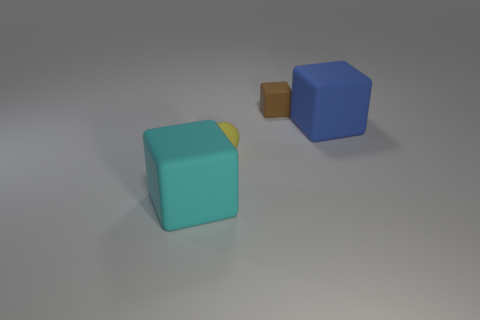Add 4 yellow matte objects. How many objects exist? 8 Subtract all cubes. How many objects are left? 1 Subtract 0 green spheres. How many objects are left? 4 Subtract all large blue rubber objects. Subtract all tiny things. How many objects are left? 1 Add 4 small yellow spheres. How many small yellow spheres are left? 5 Add 1 tiny rubber blocks. How many tiny rubber blocks exist? 2 